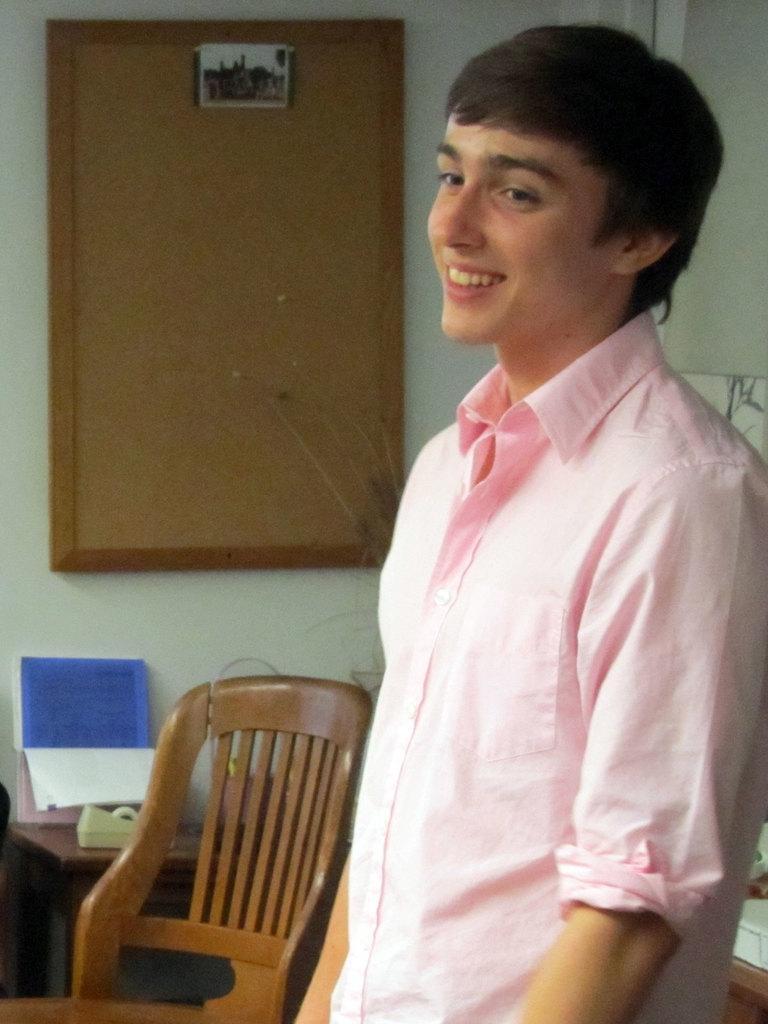Please provide a concise description of this image. In this picture we can see a person is standing and smiling, in background we can see a chair, a table, calendar, and a notice board on the wall. 